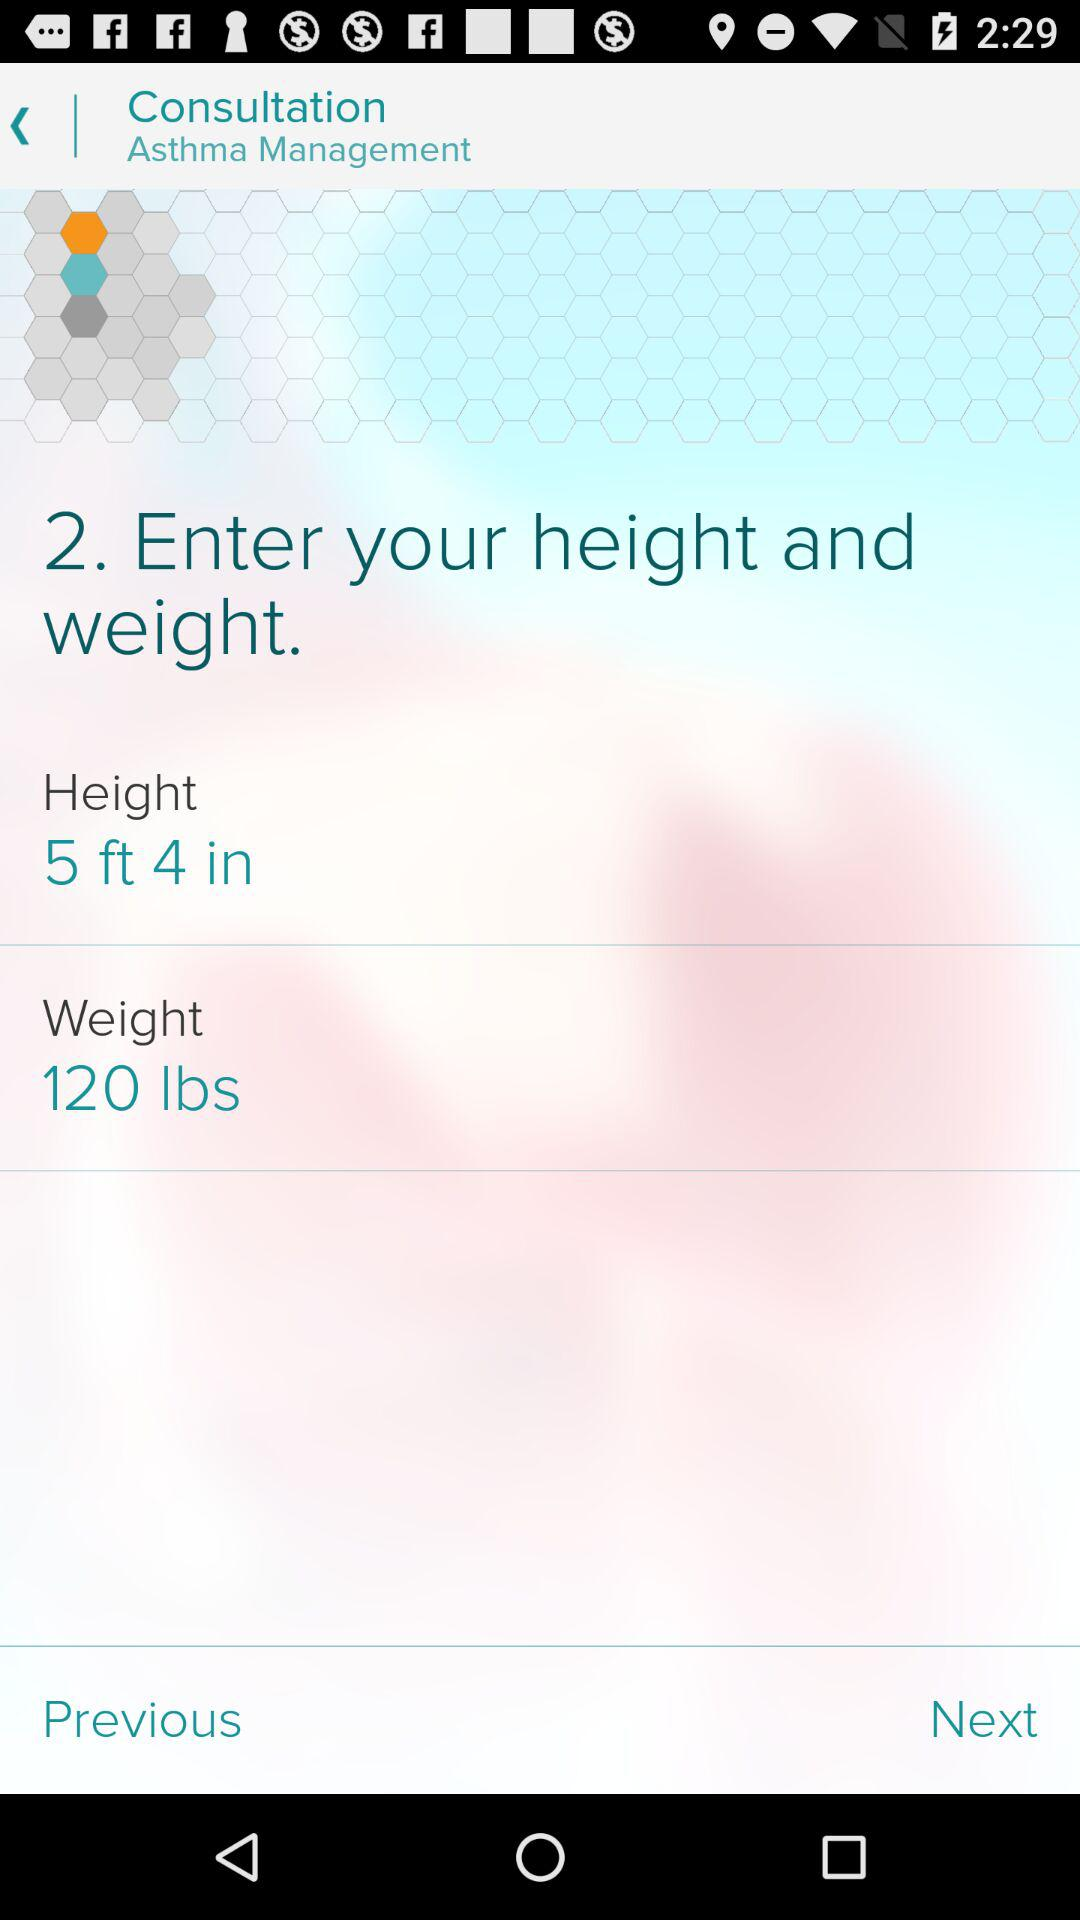What is the height? The height is 5 feet 4 inches. 